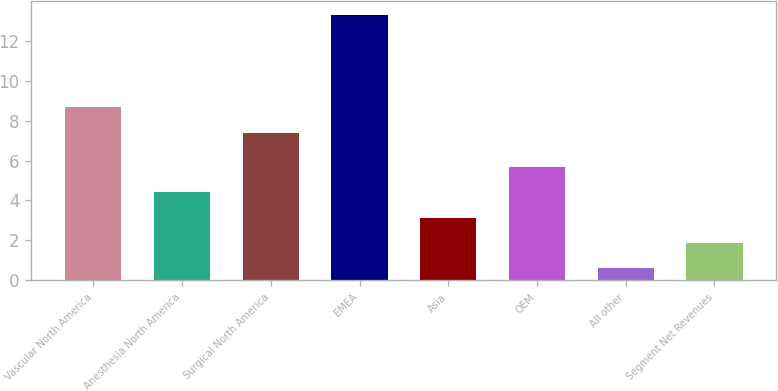<chart> <loc_0><loc_0><loc_500><loc_500><bar_chart><fcel>Vascular North America<fcel>Anesthesia North America<fcel>Surgical North America<fcel>EMEA<fcel>Asia<fcel>OEM<fcel>All other<fcel>Segment Net Revenues<nl><fcel>8.67<fcel>4.41<fcel>7.4<fcel>13.3<fcel>3.14<fcel>5.68<fcel>0.6<fcel>1.87<nl></chart> 